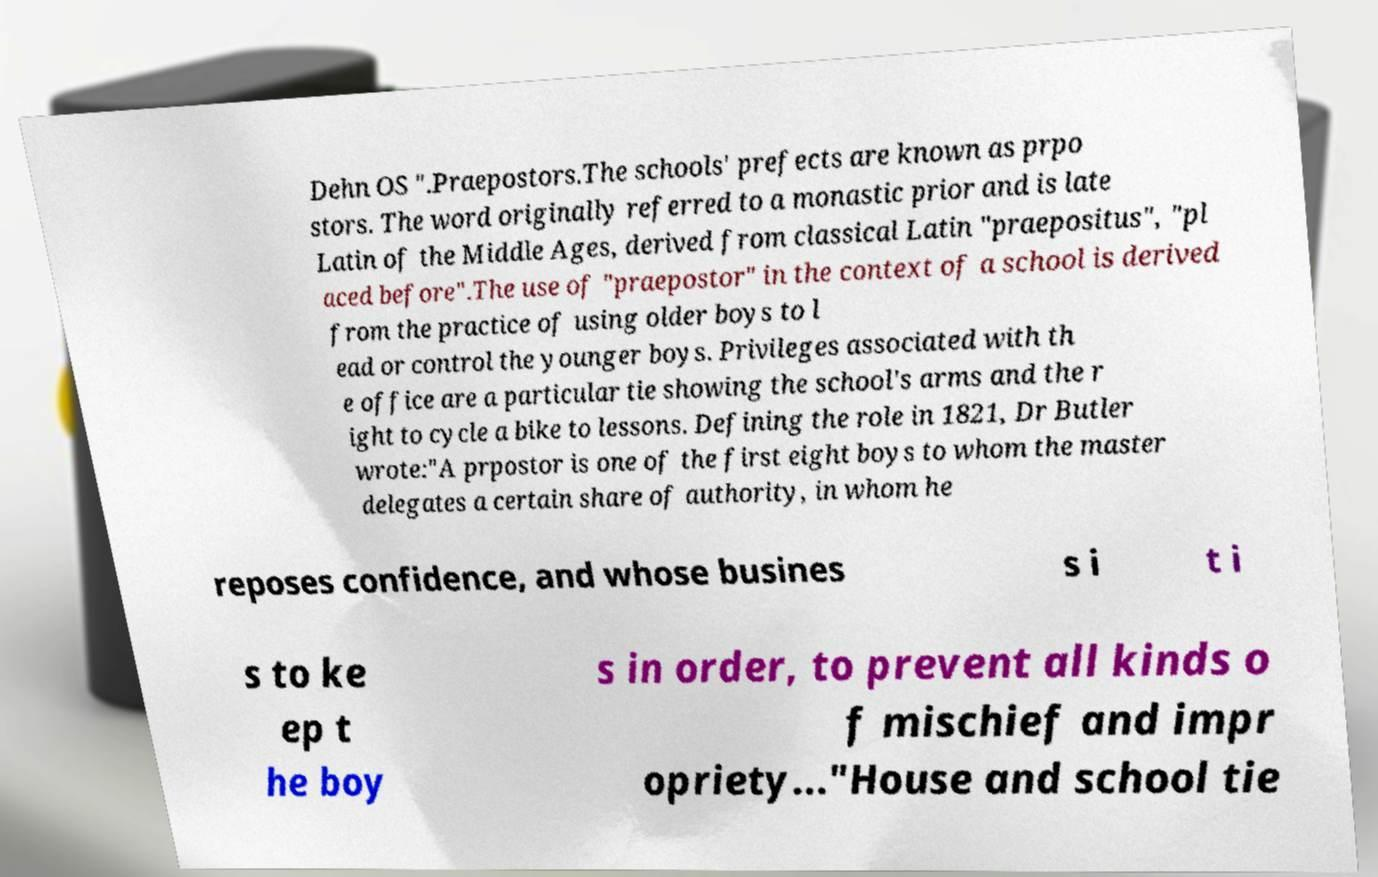Please read and relay the text visible in this image. What does it say? Dehn OS ".Praepostors.The schools' prefects are known as prpo stors. The word originally referred to a monastic prior and is late Latin of the Middle Ages, derived from classical Latin "praepositus", "pl aced before".The use of "praepostor" in the context of a school is derived from the practice of using older boys to l ead or control the younger boys. Privileges associated with th e office are a particular tie showing the school's arms and the r ight to cycle a bike to lessons. Defining the role in 1821, Dr Butler wrote:"A prpostor is one of the first eight boys to whom the master delegates a certain share of authority, in whom he reposes confidence, and whose busines s i t i s to ke ep t he boy s in order, to prevent all kinds o f mischief and impr opriety..."House and school tie 